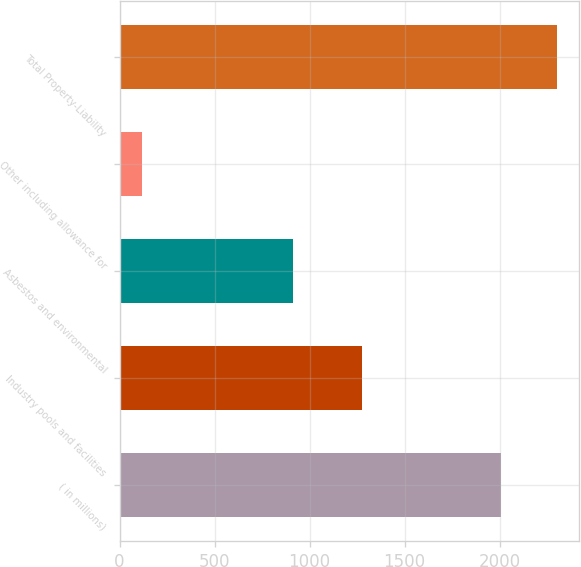<chart> <loc_0><loc_0><loc_500><loc_500><bar_chart><fcel>( in millions)<fcel>Industry pools and facilities<fcel>Asbestos and environmental<fcel>Other including allowance for<fcel>Total Property-Liability<nl><fcel>2007<fcel>1275<fcel>912<fcel>117<fcel>2304<nl></chart> 